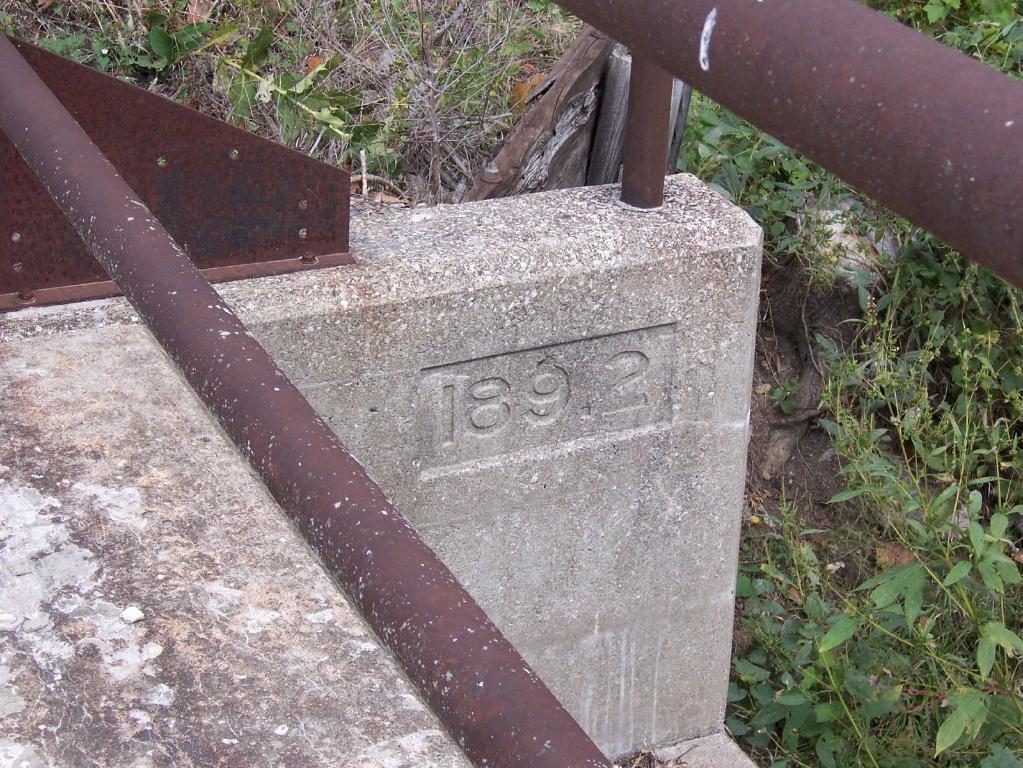Describe this image in one or two sentences. In this image I can able to see a stone with numbers on it. Also there are iron rods, a wooden object and in the background there are plants and grass. 